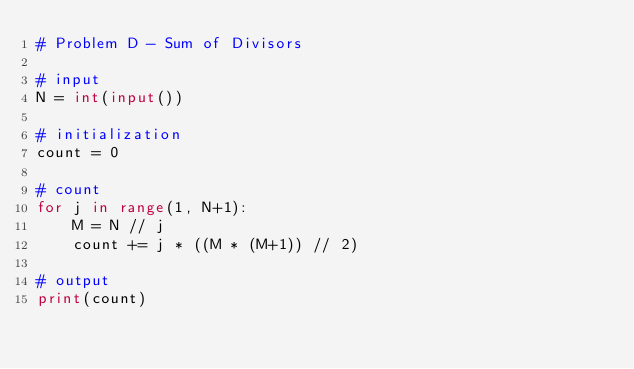<code> <loc_0><loc_0><loc_500><loc_500><_Python_># Problem D - Sum of Divisors

# input
N = int(input())

# initialization
count = 0

# count
for j in range(1, N+1):
    M = N // j
    count += j * ((M * (M+1)) // 2)

# output
print(count)
</code> 